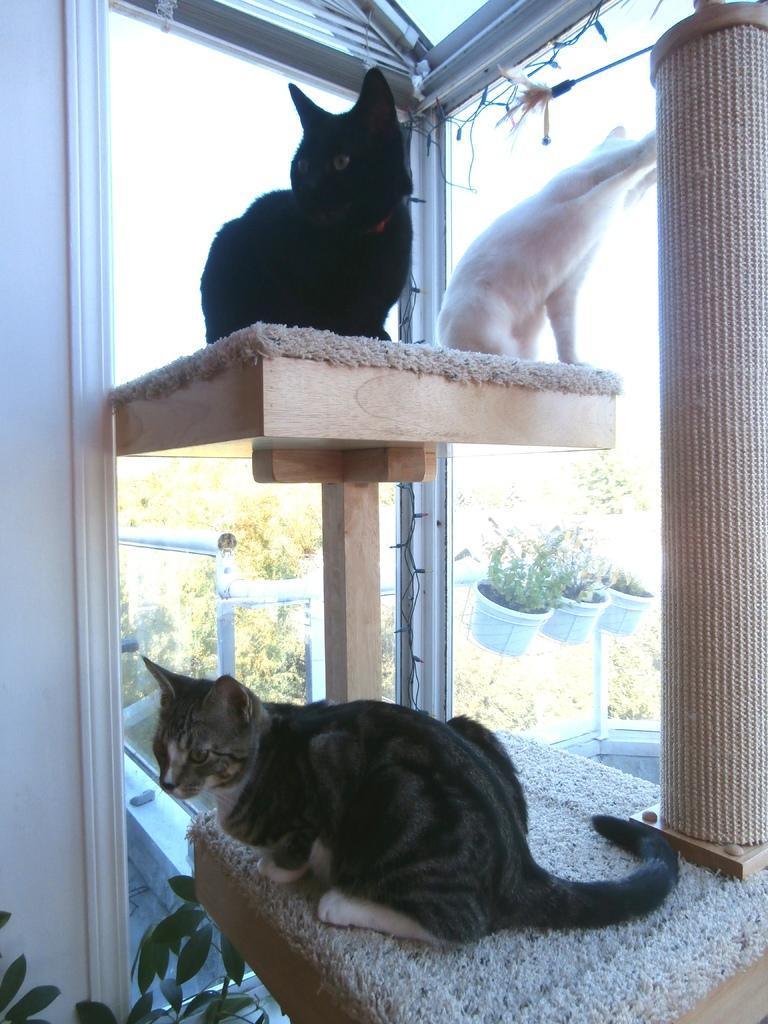Describe this image in one or two sentences. In this image I can see a wooden stand on which there are few cats sitting. On the right side there is wooden trunk. at the back of it there is a glass through which we can see the outside view. In the outside there are many plants and railing. On the left side there is a wall. At the bottom few leaves are visible. 